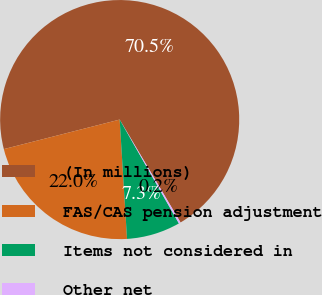Convert chart. <chart><loc_0><loc_0><loc_500><loc_500><pie_chart><fcel>(In millions)<fcel>FAS/CAS pension adjustment<fcel>Items not considered in<fcel>Other net<nl><fcel>70.48%<fcel>22.01%<fcel>7.27%<fcel>0.25%<nl></chart> 